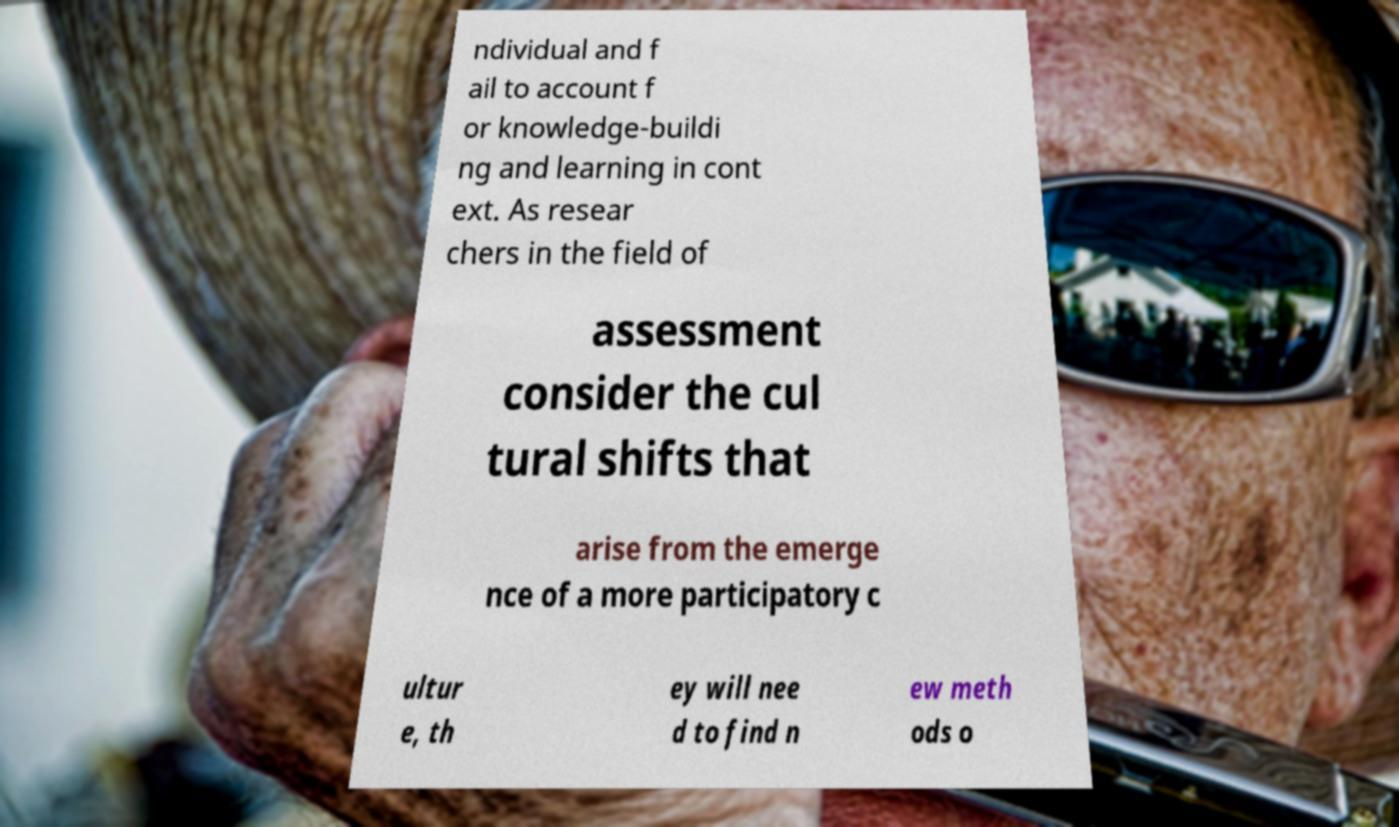Can you read and provide the text displayed in the image?This photo seems to have some interesting text. Can you extract and type it out for me? ndividual and f ail to account f or knowledge-buildi ng and learning in cont ext. As resear chers in the field of assessment consider the cul tural shifts that arise from the emerge nce of a more participatory c ultur e, th ey will nee d to find n ew meth ods o 